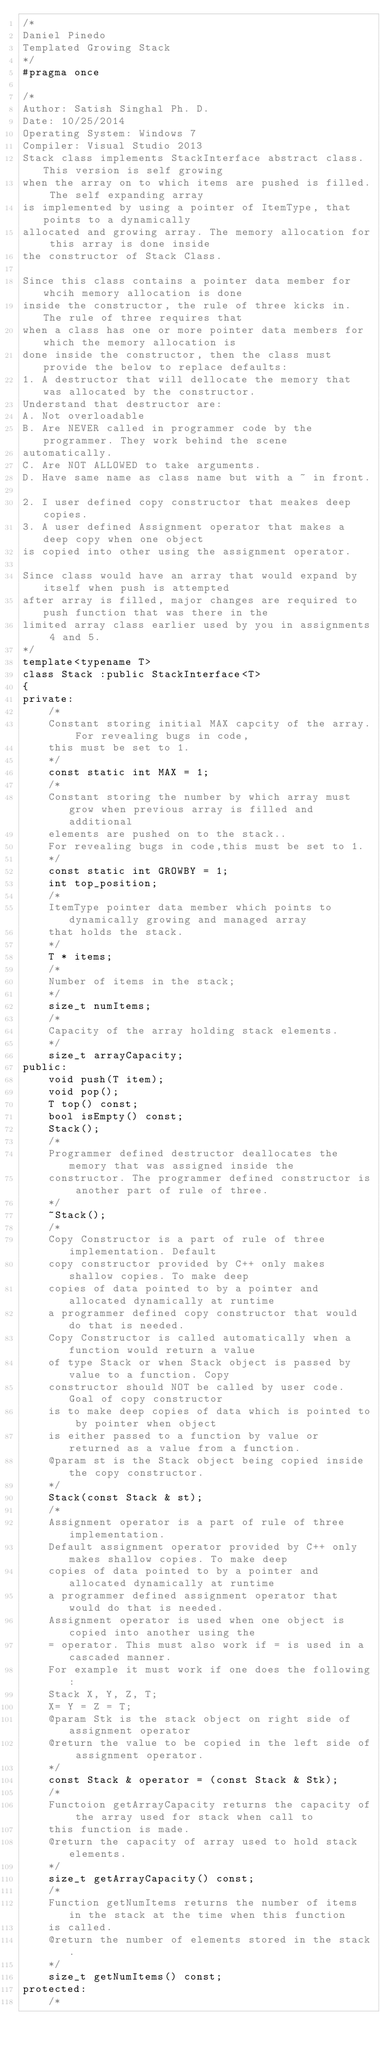<code> <loc_0><loc_0><loc_500><loc_500><_C_>/*
Daniel Pinedo
Templated Growing Stack
*/
#pragma once

/*
Author: Satish Singhal Ph. D.
Date: 10/25/2014
Operating System: Windows 7
Compiler: Visual Studio 2013
Stack class implements StackInterface abstract class. This version is self growing
when the array on to which items are pushed is filled. The self expanding array
is implemented by using a pointer of ItemType, that points to a dynamically
allocated and growing array. The memory allocation for this array is done inside
the constructor of Stack Class.

Since this class contains a pointer data member for whcih memory allocation is done
inside the constructor, the rule of three kicks in. The rule of three requires that
when a class has one or more pointer data members for which the memory allocation is
done inside the constructor, then the class must provide the below to replace defaults:
1. A destructor that will dellocate the memory that was allocated by the constructor.
Understand that destructor are:
A. Not overloadable
B. Are NEVER called in programmer code by the programmer. They work behind the scene 
automatically.
C. Are NOT ALLOWED to take arguments.
D. Have same name as class name but with a ~ in front.

2. I user defined copy constructor that meakes deep copies.
3. A user defined Assignment operator that makes a deep copy when one object
is copied into other using the assignment operator.

Since class would have an array that would expand by itself when push is attempted
after array is filled, major changes are required to push function that was there in the
limited array class earlier used by you in assignments 4 and 5.
*/
template<typename T>
class Stack :public StackInterface<T>
{
private:
	/*
	Constant storing initial MAX capcity of the array. For revealing bugs in code, 
	this must be set to 1.
	*/
	const static int MAX = 1;
	/*
	Constant storing the number by which array must grow when previous array is filled and additional
	elements are pushed on to the stack.. 
	For revealing bugs in code,this must be set to 1.
	*/
	const static int GROWBY = 1;
	int top_position;
	/*
	ItemType pointer data member which points to dynamically growing and managed array
	that holds the stack.
	*/
	T * items;
	/*
	Number of items in the stack;
	*/
	size_t numItems;
	/*
	Capacity of the array holding stack elements.
	*/
	size_t arrayCapacity;
public:
	void push(T item);
	void pop();
	T top() const;
	bool isEmpty() const;
	Stack();
	/*
	Programmer defined destructor deallocates the memory that was assigned inside the
	constructor. The programmer defined constructor is another part of rule of three.
	*/
	~Stack();
	/*
	Copy Constructor is a part of rule of three implementation. Default 
	copy constructor provided by C++ only makes shallow copies. To make deep
	copies of data pointed to by a pointer and allocated dynamically at runtime
	a programmer defined copy constructor that would do that is needed.
	Copy Constructor is called automatically when a function would return a value
	of type Stack or when Stack object is passed by value to a function. Copy 
	constructor should NOT be called by user code. Goal of copy constructor
	is to make deep copies of data which is pointed to by pointer when object
	is either passed to a function by value or returned as a value from a function.
	@param st is the Stack object being copied inside the copy constructor.
	*/
	Stack(const Stack & st);
	/*
	Assignment operator is a part of rule of three implementation.
	Default assignment operator provided by C++ only makes shallow copies. To make deep
	copies of data pointed to by a pointer and allocated dynamically at runtime
	a programmer defined assignment operator that would do that is needed.
	Assignment operator is used when one object is copied into another using the
	= operator. This must also work if = is used in a cascaded manner.
	For example it must work if one does the following:
	Stack X, Y, Z, T;
	X= Y = Z = T;
	@param Stk is the stack object on right side of assignment operator
	@return the value to be copied in the left side of assignment operator.
	*/
	const Stack & operator = (const Stack & Stk);
	/*
	Functoion getArrayCapacity returns the capacity of the array used for stack when call to
	this function is made.
	@return the capacity of array used to hold stack elements.
	*/
	size_t getArrayCapacity() const;
	/*
	Function getNumItems returns the number of items in the stack at the time when this function
	is called.
	@return the number of elements stored in the stack.
	*/
	size_t getNumItems() const;
protected:
	/*</code> 